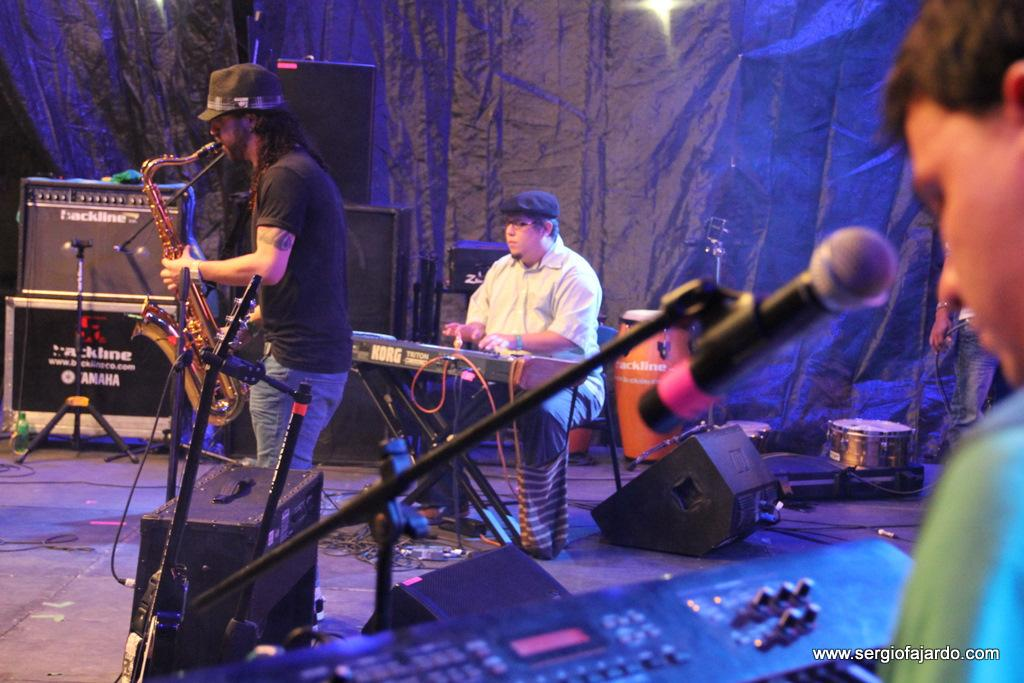How many people are in the image? There are four men in the image. What are the men doing in the image? The men are near musical instruments. What can be seen in the background of the image? There is light, speakers, and equipment visible in the background of the image. How many rings are the men wearing on their fingers in the image? There is no information about rings or any jewelry in the image; the focus is on the men being near musical instruments. 